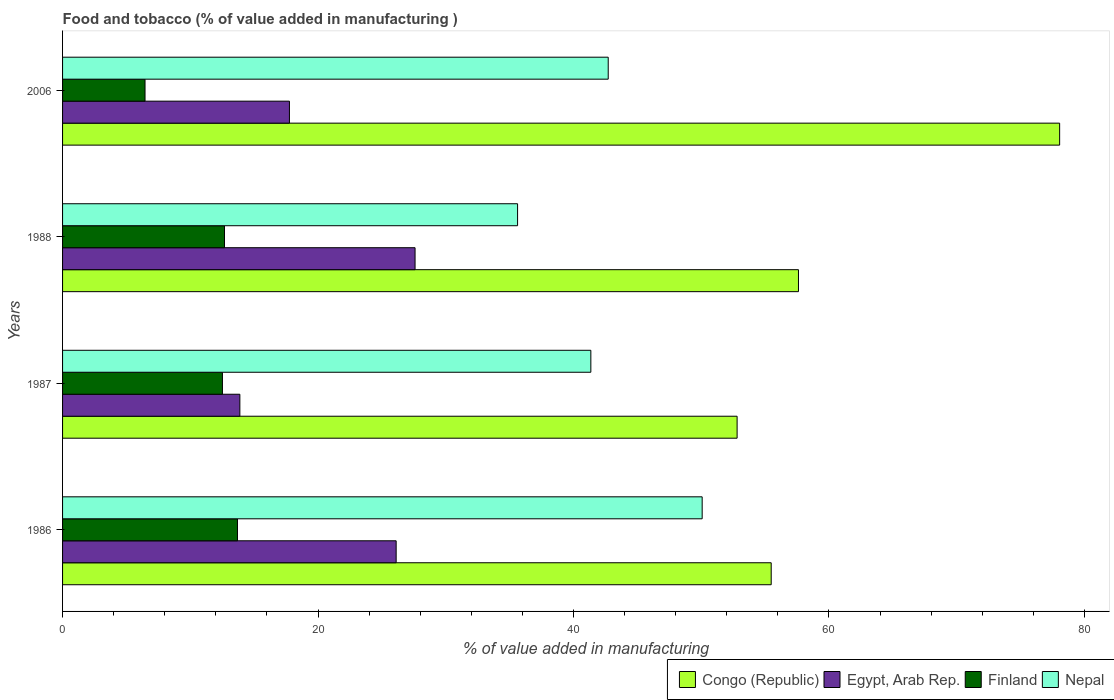How many different coloured bars are there?
Your answer should be compact. 4. How many groups of bars are there?
Make the answer very short. 4. Are the number of bars per tick equal to the number of legend labels?
Provide a succinct answer. Yes. Are the number of bars on each tick of the Y-axis equal?
Offer a terse response. Yes. How many bars are there on the 1st tick from the top?
Make the answer very short. 4. How many bars are there on the 3rd tick from the bottom?
Provide a succinct answer. 4. What is the value added in manufacturing food and tobacco in Finland in 1988?
Ensure brevity in your answer.  12.68. Across all years, what is the maximum value added in manufacturing food and tobacco in Congo (Republic)?
Your answer should be very brief. 78.06. Across all years, what is the minimum value added in manufacturing food and tobacco in Egypt, Arab Rep.?
Your answer should be compact. 13.88. In which year was the value added in manufacturing food and tobacco in Egypt, Arab Rep. maximum?
Provide a succinct answer. 1988. In which year was the value added in manufacturing food and tobacco in Nepal minimum?
Your response must be concise. 1988. What is the total value added in manufacturing food and tobacco in Finland in the graph?
Offer a terse response. 45.35. What is the difference between the value added in manufacturing food and tobacco in Nepal in 1987 and that in 1988?
Your response must be concise. 5.74. What is the difference between the value added in manufacturing food and tobacco in Congo (Republic) in 1988 and the value added in manufacturing food and tobacco in Finland in 1986?
Offer a very short reply. 43.92. What is the average value added in manufacturing food and tobacco in Congo (Republic) per year?
Keep it short and to the point. 60.99. In the year 1986, what is the difference between the value added in manufacturing food and tobacco in Congo (Republic) and value added in manufacturing food and tobacco in Nepal?
Give a very brief answer. 5.4. What is the ratio of the value added in manufacturing food and tobacco in Congo (Republic) in 1987 to that in 1988?
Offer a terse response. 0.92. Is the difference between the value added in manufacturing food and tobacco in Congo (Republic) in 1986 and 2006 greater than the difference between the value added in manufacturing food and tobacco in Nepal in 1986 and 2006?
Make the answer very short. No. What is the difference between the highest and the second highest value added in manufacturing food and tobacco in Congo (Republic)?
Offer a terse response. 20.45. What is the difference between the highest and the lowest value added in manufacturing food and tobacco in Finland?
Ensure brevity in your answer.  7.24. In how many years, is the value added in manufacturing food and tobacco in Nepal greater than the average value added in manufacturing food and tobacco in Nepal taken over all years?
Offer a terse response. 2. Is the sum of the value added in manufacturing food and tobacco in Nepal in 1987 and 1988 greater than the maximum value added in manufacturing food and tobacco in Egypt, Arab Rep. across all years?
Make the answer very short. Yes. Is it the case that in every year, the sum of the value added in manufacturing food and tobacco in Nepal and value added in manufacturing food and tobacco in Congo (Republic) is greater than the sum of value added in manufacturing food and tobacco in Egypt, Arab Rep. and value added in manufacturing food and tobacco in Finland?
Ensure brevity in your answer.  Yes. What does the 3rd bar from the top in 1986 represents?
Give a very brief answer. Egypt, Arab Rep. What does the 1st bar from the bottom in 1988 represents?
Offer a terse response. Congo (Republic). How many years are there in the graph?
Your answer should be very brief. 4. What is the difference between two consecutive major ticks on the X-axis?
Your response must be concise. 20. Does the graph contain grids?
Your answer should be very brief. No. Where does the legend appear in the graph?
Offer a very short reply. Bottom right. How are the legend labels stacked?
Ensure brevity in your answer.  Horizontal. What is the title of the graph?
Offer a terse response. Food and tobacco (% of value added in manufacturing ). What is the label or title of the X-axis?
Offer a terse response. % of value added in manufacturing. What is the % of value added in manufacturing in Congo (Republic) in 1986?
Offer a terse response. 55.48. What is the % of value added in manufacturing of Egypt, Arab Rep. in 1986?
Your answer should be compact. 26.12. What is the % of value added in manufacturing of Finland in 1986?
Give a very brief answer. 13.69. What is the % of value added in manufacturing of Nepal in 1986?
Offer a terse response. 50.08. What is the % of value added in manufacturing of Congo (Republic) in 1987?
Your answer should be compact. 52.81. What is the % of value added in manufacturing in Egypt, Arab Rep. in 1987?
Provide a short and direct response. 13.88. What is the % of value added in manufacturing in Finland in 1987?
Your response must be concise. 12.52. What is the % of value added in manufacturing in Nepal in 1987?
Ensure brevity in your answer.  41.36. What is the % of value added in manufacturing in Congo (Republic) in 1988?
Make the answer very short. 57.61. What is the % of value added in manufacturing of Egypt, Arab Rep. in 1988?
Make the answer very short. 27.6. What is the % of value added in manufacturing in Finland in 1988?
Keep it short and to the point. 12.68. What is the % of value added in manufacturing in Nepal in 1988?
Keep it short and to the point. 35.62. What is the % of value added in manufacturing of Congo (Republic) in 2006?
Give a very brief answer. 78.06. What is the % of value added in manufacturing in Egypt, Arab Rep. in 2006?
Provide a short and direct response. 17.76. What is the % of value added in manufacturing in Finland in 2006?
Provide a short and direct response. 6.46. What is the % of value added in manufacturing in Nepal in 2006?
Offer a terse response. 42.72. Across all years, what is the maximum % of value added in manufacturing in Congo (Republic)?
Ensure brevity in your answer.  78.06. Across all years, what is the maximum % of value added in manufacturing of Egypt, Arab Rep.?
Offer a terse response. 27.6. Across all years, what is the maximum % of value added in manufacturing of Finland?
Your response must be concise. 13.69. Across all years, what is the maximum % of value added in manufacturing in Nepal?
Your answer should be compact. 50.08. Across all years, what is the minimum % of value added in manufacturing of Congo (Republic)?
Offer a terse response. 52.81. Across all years, what is the minimum % of value added in manufacturing in Egypt, Arab Rep.?
Ensure brevity in your answer.  13.88. Across all years, what is the minimum % of value added in manufacturing of Finland?
Your response must be concise. 6.46. Across all years, what is the minimum % of value added in manufacturing of Nepal?
Give a very brief answer. 35.62. What is the total % of value added in manufacturing in Congo (Republic) in the graph?
Your answer should be very brief. 243.97. What is the total % of value added in manufacturing of Egypt, Arab Rep. in the graph?
Offer a terse response. 85.36. What is the total % of value added in manufacturing of Finland in the graph?
Your answer should be compact. 45.35. What is the total % of value added in manufacturing of Nepal in the graph?
Your response must be concise. 169.78. What is the difference between the % of value added in manufacturing of Congo (Republic) in 1986 and that in 1987?
Make the answer very short. 2.67. What is the difference between the % of value added in manufacturing of Egypt, Arab Rep. in 1986 and that in 1987?
Your response must be concise. 12.24. What is the difference between the % of value added in manufacturing of Finland in 1986 and that in 1987?
Give a very brief answer. 1.18. What is the difference between the % of value added in manufacturing of Nepal in 1986 and that in 1987?
Provide a succinct answer. 8.72. What is the difference between the % of value added in manufacturing of Congo (Republic) in 1986 and that in 1988?
Offer a terse response. -2.13. What is the difference between the % of value added in manufacturing of Egypt, Arab Rep. in 1986 and that in 1988?
Your answer should be very brief. -1.48. What is the difference between the % of value added in manufacturing in Finland in 1986 and that in 1988?
Offer a very short reply. 1.02. What is the difference between the % of value added in manufacturing in Nepal in 1986 and that in 1988?
Your answer should be compact. 14.45. What is the difference between the % of value added in manufacturing in Congo (Republic) in 1986 and that in 2006?
Your response must be concise. -22.58. What is the difference between the % of value added in manufacturing of Egypt, Arab Rep. in 1986 and that in 2006?
Provide a short and direct response. 8.36. What is the difference between the % of value added in manufacturing in Finland in 1986 and that in 2006?
Make the answer very short. 7.24. What is the difference between the % of value added in manufacturing in Nepal in 1986 and that in 2006?
Your response must be concise. 7.36. What is the difference between the % of value added in manufacturing of Congo (Republic) in 1987 and that in 1988?
Keep it short and to the point. -4.8. What is the difference between the % of value added in manufacturing of Egypt, Arab Rep. in 1987 and that in 1988?
Ensure brevity in your answer.  -13.72. What is the difference between the % of value added in manufacturing of Finland in 1987 and that in 1988?
Make the answer very short. -0.16. What is the difference between the % of value added in manufacturing in Nepal in 1987 and that in 1988?
Provide a succinct answer. 5.74. What is the difference between the % of value added in manufacturing of Congo (Republic) in 1987 and that in 2006?
Ensure brevity in your answer.  -25.25. What is the difference between the % of value added in manufacturing in Egypt, Arab Rep. in 1987 and that in 2006?
Give a very brief answer. -3.88. What is the difference between the % of value added in manufacturing of Finland in 1987 and that in 2006?
Your answer should be very brief. 6.06. What is the difference between the % of value added in manufacturing of Nepal in 1987 and that in 2006?
Give a very brief answer. -1.36. What is the difference between the % of value added in manufacturing of Congo (Republic) in 1988 and that in 2006?
Provide a succinct answer. -20.45. What is the difference between the % of value added in manufacturing in Egypt, Arab Rep. in 1988 and that in 2006?
Make the answer very short. 9.84. What is the difference between the % of value added in manufacturing of Finland in 1988 and that in 2006?
Offer a terse response. 6.22. What is the difference between the % of value added in manufacturing of Nepal in 1988 and that in 2006?
Ensure brevity in your answer.  -7.1. What is the difference between the % of value added in manufacturing of Congo (Republic) in 1986 and the % of value added in manufacturing of Egypt, Arab Rep. in 1987?
Keep it short and to the point. 41.6. What is the difference between the % of value added in manufacturing of Congo (Republic) in 1986 and the % of value added in manufacturing of Finland in 1987?
Offer a terse response. 42.96. What is the difference between the % of value added in manufacturing in Congo (Republic) in 1986 and the % of value added in manufacturing in Nepal in 1987?
Your response must be concise. 14.12. What is the difference between the % of value added in manufacturing of Egypt, Arab Rep. in 1986 and the % of value added in manufacturing of Finland in 1987?
Ensure brevity in your answer.  13.6. What is the difference between the % of value added in manufacturing of Egypt, Arab Rep. in 1986 and the % of value added in manufacturing of Nepal in 1987?
Keep it short and to the point. -15.24. What is the difference between the % of value added in manufacturing of Finland in 1986 and the % of value added in manufacturing of Nepal in 1987?
Offer a very short reply. -27.66. What is the difference between the % of value added in manufacturing in Congo (Republic) in 1986 and the % of value added in manufacturing in Egypt, Arab Rep. in 1988?
Provide a short and direct response. 27.88. What is the difference between the % of value added in manufacturing of Congo (Republic) in 1986 and the % of value added in manufacturing of Finland in 1988?
Your answer should be compact. 42.8. What is the difference between the % of value added in manufacturing of Congo (Republic) in 1986 and the % of value added in manufacturing of Nepal in 1988?
Your response must be concise. 19.86. What is the difference between the % of value added in manufacturing in Egypt, Arab Rep. in 1986 and the % of value added in manufacturing in Finland in 1988?
Provide a short and direct response. 13.44. What is the difference between the % of value added in manufacturing of Egypt, Arab Rep. in 1986 and the % of value added in manufacturing of Nepal in 1988?
Your answer should be compact. -9.51. What is the difference between the % of value added in manufacturing of Finland in 1986 and the % of value added in manufacturing of Nepal in 1988?
Make the answer very short. -21.93. What is the difference between the % of value added in manufacturing of Congo (Republic) in 1986 and the % of value added in manufacturing of Egypt, Arab Rep. in 2006?
Your response must be concise. 37.72. What is the difference between the % of value added in manufacturing in Congo (Republic) in 1986 and the % of value added in manufacturing in Finland in 2006?
Give a very brief answer. 49.02. What is the difference between the % of value added in manufacturing in Congo (Republic) in 1986 and the % of value added in manufacturing in Nepal in 2006?
Offer a very short reply. 12.76. What is the difference between the % of value added in manufacturing in Egypt, Arab Rep. in 1986 and the % of value added in manufacturing in Finland in 2006?
Your response must be concise. 19.66. What is the difference between the % of value added in manufacturing in Egypt, Arab Rep. in 1986 and the % of value added in manufacturing in Nepal in 2006?
Your answer should be very brief. -16.6. What is the difference between the % of value added in manufacturing of Finland in 1986 and the % of value added in manufacturing of Nepal in 2006?
Your response must be concise. -29.03. What is the difference between the % of value added in manufacturing of Congo (Republic) in 1987 and the % of value added in manufacturing of Egypt, Arab Rep. in 1988?
Ensure brevity in your answer.  25.21. What is the difference between the % of value added in manufacturing in Congo (Republic) in 1987 and the % of value added in manufacturing in Finland in 1988?
Keep it short and to the point. 40.13. What is the difference between the % of value added in manufacturing in Congo (Republic) in 1987 and the % of value added in manufacturing in Nepal in 1988?
Give a very brief answer. 17.19. What is the difference between the % of value added in manufacturing in Egypt, Arab Rep. in 1987 and the % of value added in manufacturing in Finland in 1988?
Ensure brevity in your answer.  1.2. What is the difference between the % of value added in manufacturing in Egypt, Arab Rep. in 1987 and the % of value added in manufacturing in Nepal in 1988?
Your answer should be very brief. -21.74. What is the difference between the % of value added in manufacturing of Finland in 1987 and the % of value added in manufacturing of Nepal in 1988?
Provide a short and direct response. -23.11. What is the difference between the % of value added in manufacturing of Congo (Republic) in 1987 and the % of value added in manufacturing of Egypt, Arab Rep. in 2006?
Provide a succinct answer. 35.05. What is the difference between the % of value added in manufacturing of Congo (Republic) in 1987 and the % of value added in manufacturing of Finland in 2006?
Provide a succinct answer. 46.35. What is the difference between the % of value added in manufacturing in Congo (Republic) in 1987 and the % of value added in manufacturing in Nepal in 2006?
Your answer should be compact. 10.09. What is the difference between the % of value added in manufacturing of Egypt, Arab Rep. in 1987 and the % of value added in manufacturing of Finland in 2006?
Your answer should be very brief. 7.42. What is the difference between the % of value added in manufacturing of Egypt, Arab Rep. in 1987 and the % of value added in manufacturing of Nepal in 2006?
Your response must be concise. -28.84. What is the difference between the % of value added in manufacturing of Finland in 1987 and the % of value added in manufacturing of Nepal in 2006?
Your answer should be very brief. -30.2. What is the difference between the % of value added in manufacturing in Congo (Republic) in 1988 and the % of value added in manufacturing in Egypt, Arab Rep. in 2006?
Offer a terse response. 39.85. What is the difference between the % of value added in manufacturing of Congo (Republic) in 1988 and the % of value added in manufacturing of Finland in 2006?
Offer a terse response. 51.16. What is the difference between the % of value added in manufacturing in Congo (Republic) in 1988 and the % of value added in manufacturing in Nepal in 2006?
Your answer should be very brief. 14.89. What is the difference between the % of value added in manufacturing of Egypt, Arab Rep. in 1988 and the % of value added in manufacturing of Finland in 2006?
Offer a terse response. 21.14. What is the difference between the % of value added in manufacturing of Egypt, Arab Rep. in 1988 and the % of value added in manufacturing of Nepal in 2006?
Make the answer very short. -15.12. What is the difference between the % of value added in manufacturing of Finland in 1988 and the % of value added in manufacturing of Nepal in 2006?
Ensure brevity in your answer.  -30.04. What is the average % of value added in manufacturing in Congo (Republic) per year?
Make the answer very short. 60.99. What is the average % of value added in manufacturing of Egypt, Arab Rep. per year?
Provide a short and direct response. 21.34. What is the average % of value added in manufacturing in Finland per year?
Give a very brief answer. 11.34. What is the average % of value added in manufacturing of Nepal per year?
Ensure brevity in your answer.  42.44. In the year 1986, what is the difference between the % of value added in manufacturing of Congo (Republic) and % of value added in manufacturing of Egypt, Arab Rep.?
Your answer should be very brief. 29.36. In the year 1986, what is the difference between the % of value added in manufacturing in Congo (Republic) and % of value added in manufacturing in Finland?
Provide a succinct answer. 41.79. In the year 1986, what is the difference between the % of value added in manufacturing of Congo (Republic) and % of value added in manufacturing of Nepal?
Offer a very short reply. 5.4. In the year 1986, what is the difference between the % of value added in manufacturing in Egypt, Arab Rep. and % of value added in manufacturing in Finland?
Your answer should be very brief. 12.42. In the year 1986, what is the difference between the % of value added in manufacturing of Egypt, Arab Rep. and % of value added in manufacturing of Nepal?
Make the answer very short. -23.96. In the year 1986, what is the difference between the % of value added in manufacturing of Finland and % of value added in manufacturing of Nepal?
Give a very brief answer. -36.38. In the year 1987, what is the difference between the % of value added in manufacturing of Congo (Republic) and % of value added in manufacturing of Egypt, Arab Rep.?
Provide a short and direct response. 38.93. In the year 1987, what is the difference between the % of value added in manufacturing in Congo (Republic) and % of value added in manufacturing in Finland?
Offer a very short reply. 40.29. In the year 1987, what is the difference between the % of value added in manufacturing in Congo (Republic) and % of value added in manufacturing in Nepal?
Make the answer very short. 11.45. In the year 1987, what is the difference between the % of value added in manufacturing of Egypt, Arab Rep. and % of value added in manufacturing of Finland?
Offer a terse response. 1.36. In the year 1987, what is the difference between the % of value added in manufacturing in Egypt, Arab Rep. and % of value added in manufacturing in Nepal?
Offer a very short reply. -27.48. In the year 1987, what is the difference between the % of value added in manufacturing of Finland and % of value added in manufacturing of Nepal?
Offer a terse response. -28.84. In the year 1988, what is the difference between the % of value added in manufacturing of Congo (Republic) and % of value added in manufacturing of Egypt, Arab Rep.?
Offer a terse response. 30.02. In the year 1988, what is the difference between the % of value added in manufacturing in Congo (Republic) and % of value added in manufacturing in Finland?
Offer a terse response. 44.94. In the year 1988, what is the difference between the % of value added in manufacturing of Congo (Republic) and % of value added in manufacturing of Nepal?
Your answer should be compact. 21.99. In the year 1988, what is the difference between the % of value added in manufacturing in Egypt, Arab Rep. and % of value added in manufacturing in Finland?
Your response must be concise. 14.92. In the year 1988, what is the difference between the % of value added in manufacturing of Egypt, Arab Rep. and % of value added in manufacturing of Nepal?
Your answer should be compact. -8.03. In the year 1988, what is the difference between the % of value added in manufacturing of Finland and % of value added in manufacturing of Nepal?
Your response must be concise. -22.94. In the year 2006, what is the difference between the % of value added in manufacturing in Congo (Republic) and % of value added in manufacturing in Egypt, Arab Rep.?
Keep it short and to the point. 60.3. In the year 2006, what is the difference between the % of value added in manufacturing of Congo (Republic) and % of value added in manufacturing of Finland?
Offer a terse response. 71.61. In the year 2006, what is the difference between the % of value added in manufacturing in Congo (Republic) and % of value added in manufacturing in Nepal?
Your answer should be compact. 35.34. In the year 2006, what is the difference between the % of value added in manufacturing of Egypt, Arab Rep. and % of value added in manufacturing of Finland?
Make the answer very short. 11.31. In the year 2006, what is the difference between the % of value added in manufacturing of Egypt, Arab Rep. and % of value added in manufacturing of Nepal?
Offer a terse response. -24.96. In the year 2006, what is the difference between the % of value added in manufacturing in Finland and % of value added in manufacturing in Nepal?
Offer a very short reply. -36.26. What is the ratio of the % of value added in manufacturing in Congo (Republic) in 1986 to that in 1987?
Make the answer very short. 1.05. What is the ratio of the % of value added in manufacturing in Egypt, Arab Rep. in 1986 to that in 1987?
Your response must be concise. 1.88. What is the ratio of the % of value added in manufacturing in Finland in 1986 to that in 1987?
Make the answer very short. 1.09. What is the ratio of the % of value added in manufacturing in Nepal in 1986 to that in 1987?
Your answer should be very brief. 1.21. What is the ratio of the % of value added in manufacturing in Egypt, Arab Rep. in 1986 to that in 1988?
Provide a succinct answer. 0.95. What is the ratio of the % of value added in manufacturing of Finland in 1986 to that in 1988?
Provide a short and direct response. 1.08. What is the ratio of the % of value added in manufacturing in Nepal in 1986 to that in 1988?
Offer a very short reply. 1.41. What is the ratio of the % of value added in manufacturing in Congo (Republic) in 1986 to that in 2006?
Your answer should be compact. 0.71. What is the ratio of the % of value added in manufacturing in Egypt, Arab Rep. in 1986 to that in 2006?
Your response must be concise. 1.47. What is the ratio of the % of value added in manufacturing in Finland in 1986 to that in 2006?
Your answer should be compact. 2.12. What is the ratio of the % of value added in manufacturing in Nepal in 1986 to that in 2006?
Give a very brief answer. 1.17. What is the ratio of the % of value added in manufacturing of Congo (Republic) in 1987 to that in 1988?
Ensure brevity in your answer.  0.92. What is the ratio of the % of value added in manufacturing in Egypt, Arab Rep. in 1987 to that in 1988?
Your answer should be compact. 0.5. What is the ratio of the % of value added in manufacturing in Finland in 1987 to that in 1988?
Your answer should be very brief. 0.99. What is the ratio of the % of value added in manufacturing of Nepal in 1987 to that in 1988?
Your response must be concise. 1.16. What is the ratio of the % of value added in manufacturing in Congo (Republic) in 1987 to that in 2006?
Make the answer very short. 0.68. What is the ratio of the % of value added in manufacturing of Egypt, Arab Rep. in 1987 to that in 2006?
Offer a very short reply. 0.78. What is the ratio of the % of value added in manufacturing of Finland in 1987 to that in 2006?
Provide a short and direct response. 1.94. What is the ratio of the % of value added in manufacturing of Nepal in 1987 to that in 2006?
Your answer should be very brief. 0.97. What is the ratio of the % of value added in manufacturing of Congo (Republic) in 1988 to that in 2006?
Ensure brevity in your answer.  0.74. What is the ratio of the % of value added in manufacturing in Egypt, Arab Rep. in 1988 to that in 2006?
Make the answer very short. 1.55. What is the ratio of the % of value added in manufacturing in Finland in 1988 to that in 2006?
Provide a succinct answer. 1.96. What is the ratio of the % of value added in manufacturing in Nepal in 1988 to that in 2006?
Make the answer very short. 0.83. What is the difference between the highest and the second highest % of value added in manufacturing of Congo (Republic)?
Keep it short and to the point. 20.45. What is the difference between the highest and the second highest % of value added in manufacturing in Egypt, Arab Rep.?
Ensure brevity in your answer.  1.48. What is the difference between the highest and the second highest % of value added in manufacturing of Finland?
Your response must be concise. 1.02. What is the difference between the highest and the second highest % of value added in manufacturing of Nepal?
Give a very brief answer. 7.36. What is the difference between the highest and the lowest % of value added in manufacturing of Congo (Republic)?
Provide a short and direct response. 25.25. What is the difference between the highest and the lowest % of value added in manufacturing of Egypt, Arab Rep.?
Keep it short and to the point. 13.72. What is the difference between the highest and the lowest % of value added in manufacturing in Finland?
Your answer should be very brief. 7.24. What is the difference between the highest and the lowest % of value added in manufacturing in Nepal?
Your answer should be compact. 14.45. 